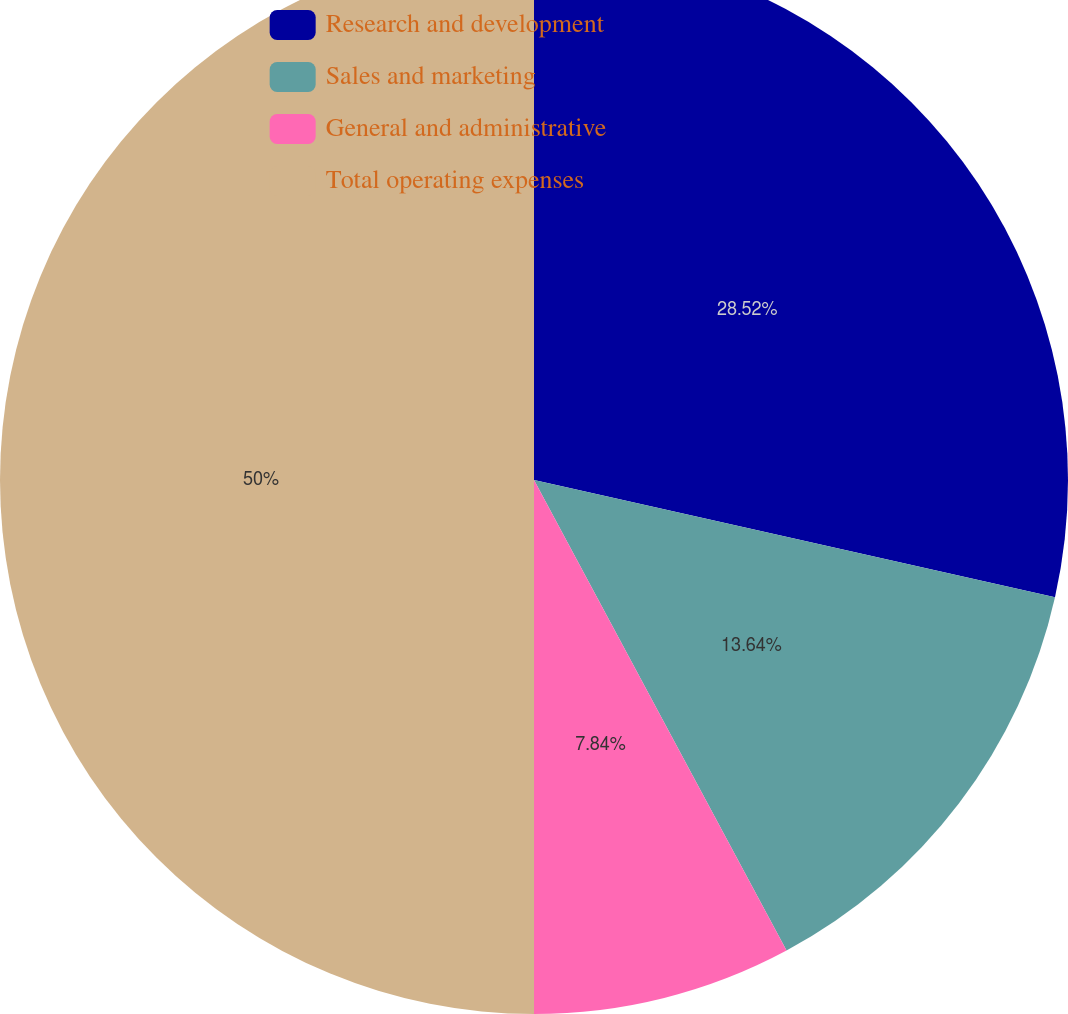Convert chart. <chart><loc_0><loc_0><loc_500><loc_500><pie_chart><fcel>Research and development<fcel>Sales and marketing<fcel>General and administrative<fcel>Total operating expenses<nl><fcel>28.52%<fcel>13.64%<fcel>7.84%<fcel>50.0%<nl></chart> 